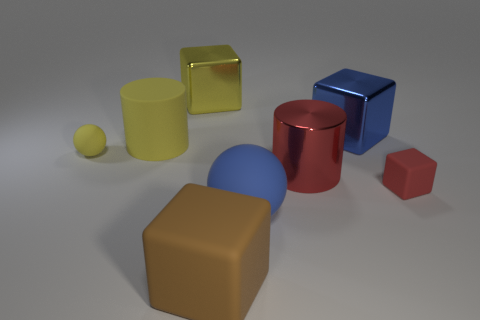Subtract all large blue metal blocks. How many blocks are left? 3 Subtract all red blocks. How many blocks are left? 3 Subtract 1 spheres. How many spheres are left? 1 Add 1 large yellow things. How many objects exist? 9 Subtract all red balls. Subtract all cyan cubes. How many balls are left? 2 Subtract all large blue matte spheres. Subtract all big red metallic objects. How many objects are left? 6 Add 1 large red metallic cylinders. How many large red metallic cylinders are left? 2 Add 4 blue metallic objects. How many blue metallic objects exist? 5 Subtract 0 green spheres. How many objects are left? 8 